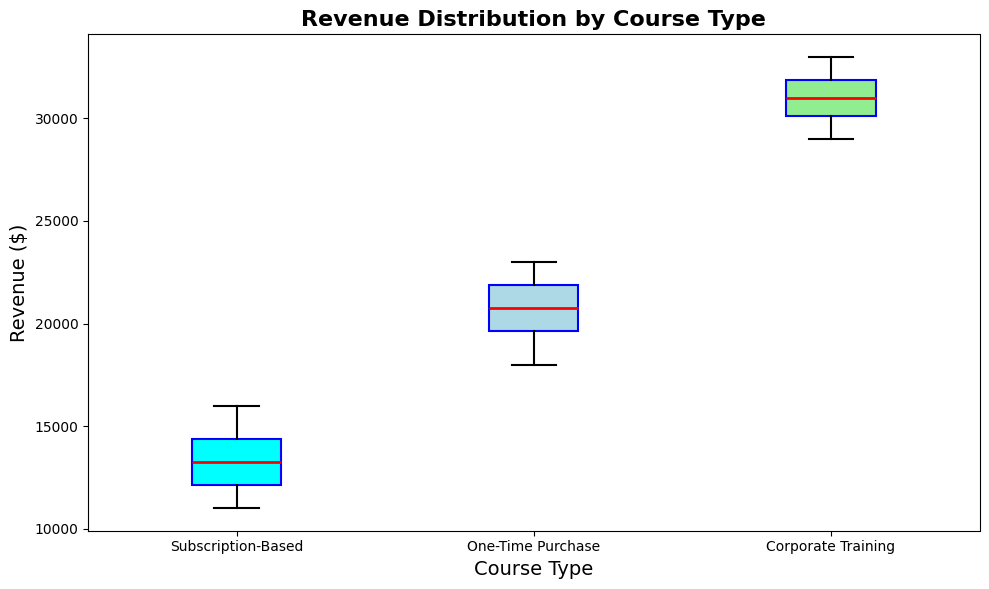What's the range of revenue for the Subscription-Based courses? The range is calculated by subtracting the minimum value from the maximum value in the Subscription-Based data set. From the plot, the minimum is $11,000 and the maximum is $16,000. Thus, the range is $16,000 - $11,000 = $5,000.
Answer: $5,000 Which course type has the highest median revenue? By looking at the median line inside the boxes, the Corporate Training has the highest median, which is visually represented by the red line well above the others.
Answer: Corporate Training Compare the spread (interquartile range, IQR) of revenues between One-Time Purchase and Corporate Training courses. Which one is higher? The IQR is the difference between the upper quartile (75th percentile) and the lower quartile (25th percentile). For One-Time Purchase, the IQR is between $18,000 and $22,500, making it $4,500. For Corporate Training, it is between $29,000 and $32,500, making it $3,500. The IQR for One-Time Purchase is higher.
Answer: One-Time Purchase Which course type shows the least variability in revenue distribution? Variability is represented by the spread of the box plot. The Subscription-Based courses have the narrowest box, indicating the least variability.
Answer: Subscription-Based What is the difference between the median revenue of Subscription-Based and Corporate Training courses? The median for Subscription-Based is shown around $13,500, while for Corporate Training, it is around $31,000. Therefore, the difference is $31,000 - $13,500 = $17,500.
Answer: $17,500 